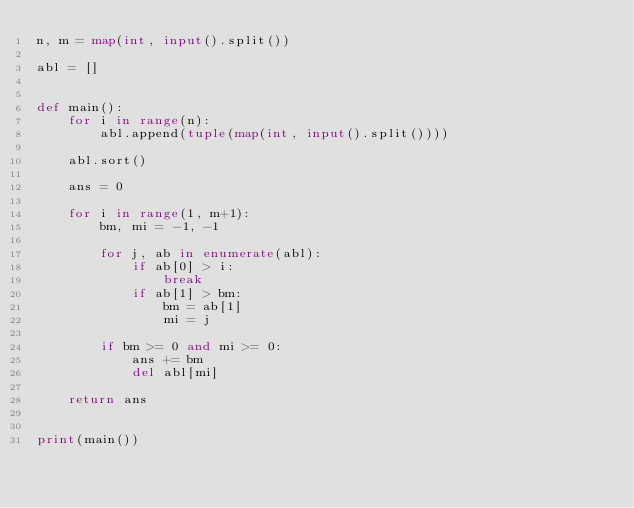<code> <loc_0><loc_0><loc_500><loc_500><_Python_>n, m = map(int, input().split())

abl = []


def main():
    for i in range(n):
        abl.append(tuple(map(int, input().split())))

    abl.sort()

    ans = 0

    for i in range(1, m+1):
        bm, mi = -1, -1

        for j, ab in enumerate(abl):
            if ab[0] > i:
                break
            if ab[1] > bm:
                bm = ab[1]
                mi = j

        if bm >= 0 and mi >= 0:
            ans += bm
            del abl[mi]

    return ans


print(main())
</code> 